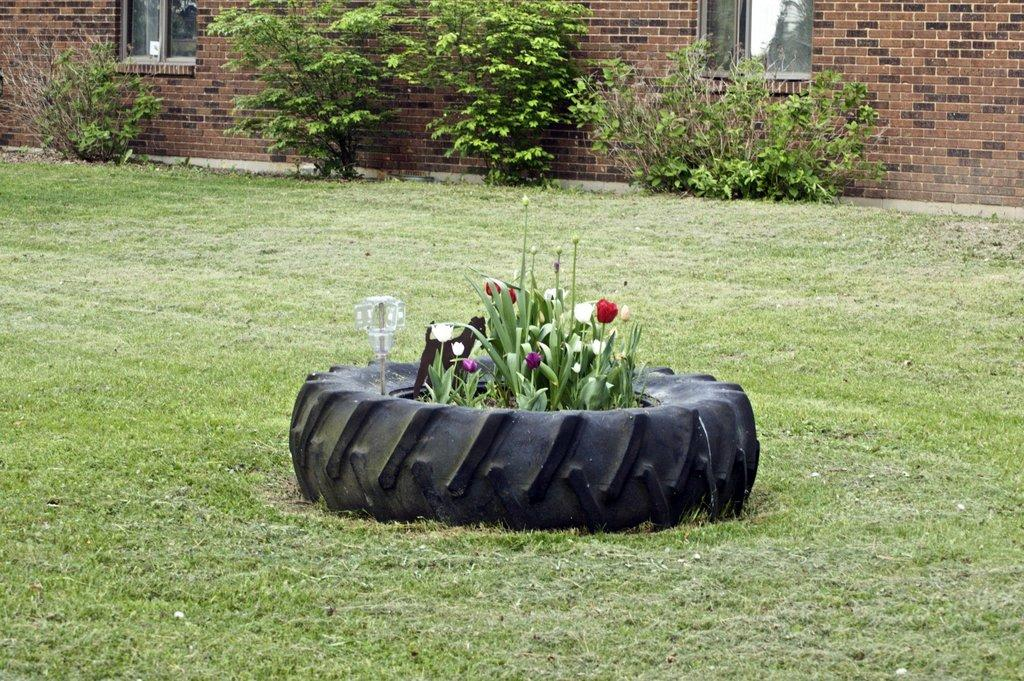What type of plants can be seen in the image? There are plants with flowers in the image. What is the object on a stick in the image? The object on a stick is not specified in the facts provided. How are the plants and object arranged in the image? The plants and object are surrounded by a tire in the image. What can be seen in the background of the image? There is a wall and windows in the background of the image. What else is present on the wall in the background of the image? There are plants on the wall in the background of the image. What is the monkey's reaction to the territory in the image? There is no monkey present in the image, so it is not possible to determine its reaction to the territory. 